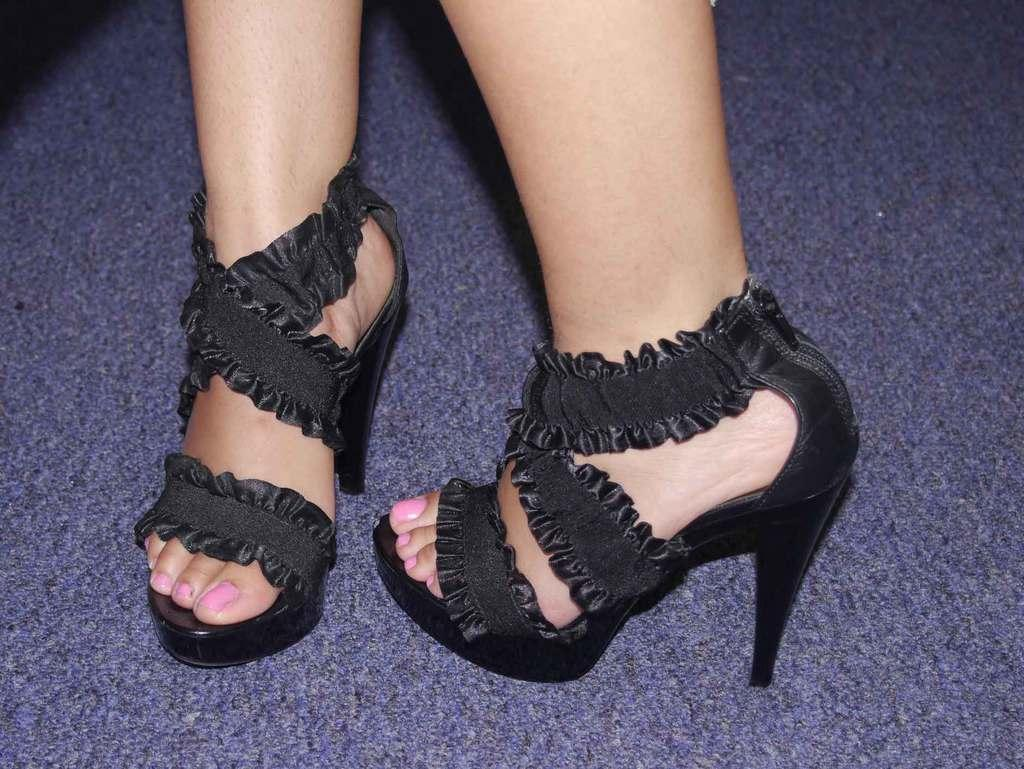What is present in the image? There is a person in the image. What part of the person's body can be seen? The person's legs are visible. What type of footwear is the person wearing? The person is wearing black footwear. How many ants can be seen crawling on the person's legs in the image? There are no ants present in the image; only the person's legs and black footwear are visible. 